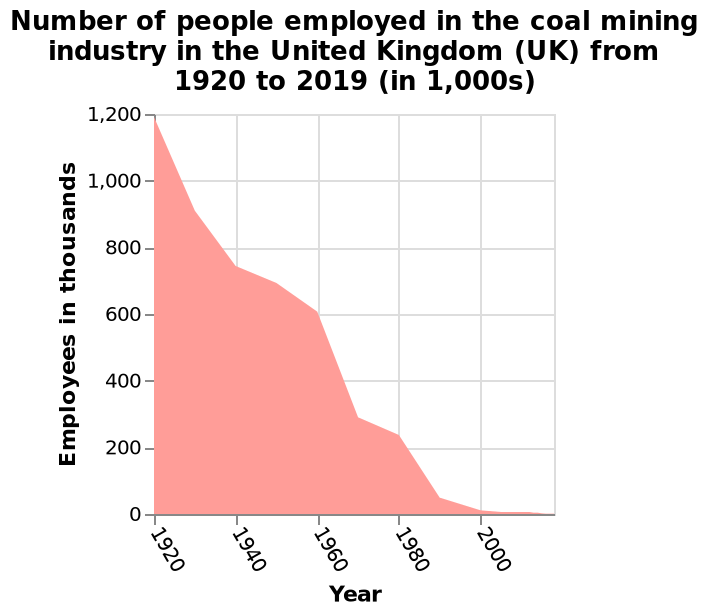<image>
What does the y-axis measure in this area plot?  The y-axis measures the number of employees in thousands. Describe the following image in detail This area plot is named Number of people employed in the coal mining industry in the United Kingdom (UK) from 1920 to 2019 (in 1,000s). The y-axis measures Employees in thousands while the x-axis plots Year. Were the drops in the number of employees in the coal mining industry consistent throughout the entire period?  No, there were gradual falls during some periods, but the drops were steeper after 1920 and 1960. 